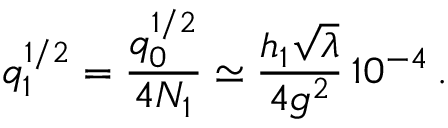<formula> <loc_0><loc_0><loc_500><loc_500>q _ { 1 } ^ { 1 / 2 } = { \frac { q _ { 0 } ^ { 1 / 2 } } { 4 N _ { 1 } } } \simeq { \frac { h _ { 1 } \sqrt { \lambda } } { 4 g ^ { 2 } } } \, 1 0 ^ { - 4 } \, .</formula> 